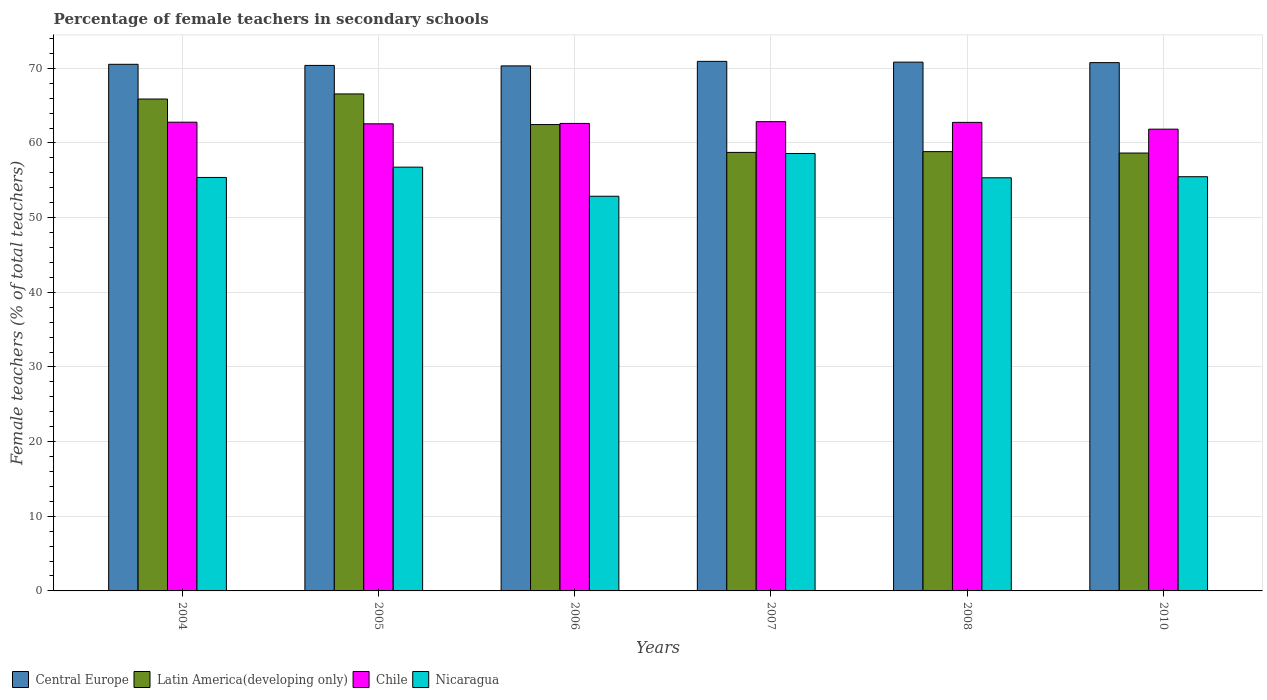How many groups of bars are there?
Offer a very short reply. 6. Are the number of bars on each tick of the X-axis equal?
Offer a very short reply. Yes. What is the label of the 4th group of bars from the left?
Give a very brief answer. 2007. In how many cases, is the number of bars for a given year not equal to the number of legend labels?
Your response must be concise. 0. What is the percentage of female teachers in Central Europe in 2004?
Offer a terse response. 70.54. Across all years, what is the maximum percentage of female teachers in Latin America(developing only)?
Your answer should be compact. 66.57. Across all years, what is the minimum percentage of female teachers in Chile?
Give a very brief answer. 61.85. In which year was the percentage of female teachers in Latin America(developing only) minimum?
Keep it short and to the point. 2010. What is the total percentage of female teachers in Latin America(developing only) in the graph?
Keep it short and to the point. 371.17. What is the difference between the percentage of female teachers in Chile in 2005 and that in 2008?
Your answer should be very brief. -0.19. What is the difference between the percentage of female teachers in Chile in 2008 and the percentage of female teachers in Central Europe in 2006?
Offer a terse response. -7.57. What is the average percentage of female teachers in Nicaragua per year?
Keep it short and to the point. 55.74. In the year 2010, what is the difference between the percentage of female teachers in Nicaragua and percentage of female teachers in Chile?
Give a very brief answer. -6.37. In how many years, is the percentage of female teachers in Nicaragua greater than 58 %?
Your response must be concise. 1. What is the ratio of the percentage of female teachers in Central Europe in 2008 to that in 2010?
Offer a very short reply. 1. What is the difference between the highest and the second highest percentage of female teachers in Chile?
Your answer should be compact. 0.07. What is the difference between the highest and the lowest percentage of female teachers in Central Europe?
Your response must be concise. 0.61. Is the sum of the percentage of female teachers in Nicaragua in 2005 and 2010 greater than the maximum percentage of female teachers in Chile across all years?
Offer a terse response. Yes. Is it the case that in every year, the sum of the percentage of female teachers in Chile and percentage of female teachers in Central Europe is greater than the sum of percentage of female teachers in Nicaragua and percentage of female teachers in Latin America(developing only)?
Ensure brevity in your answer.  Yes. What does the 1st bar from the left in 2006 represents?
Offer a terse response. Central Europe. What does the 1st bar from the right in 2006 represents?
Offer a terse response. Nicaragua. Is it the case that in every year, the sum of the percentage of female teachers in Chile and percentage of female teachers in Nicaragua is greater than the percentage of female teachers in Central Europe?
Offer a very short reply. Yes. How many bars are there?
Ensure brevity in your answer.  24. Are all the bars in the graph horizontal?
Your answer should be compact. No. How many years are there in the graph?
Make the answer very short. 6. Does the graph contain grids?
Your answer should be very brief. Yes. Where does the legend appear in the graph?
Give a very brief answer. Bottom left. How many legend labels are there?
Keep it short and to the point. 4. How are the legend labels stacked?
Give a very brief answer. Horizontal. What is the title of the graph?
Your answer should be compact. Percentage of female teachers in secondary schools. Does "Zambia" appear as one of the legend labels in the graph?
Offer a terse response. No. What is the label or title of the X-axis?
Your answer should be compact. Years. What is the label or title of the Y-axis?
Provide a succinct answer. Female teachers (% of total teachers). What is the Female teachers (% of total teachers) of Central Europe in 2004?
Give a very brief answer. 70.54. What is the Female teachers (% of total teachers) in Latin America(developing only) in 2004?
Keep it short and to the point. 65.89. What is the Female teachers (% of total teachers) in Chile in 2004?
Your answer should be compact. 62.79. What is the Female teachers (% of total teachers) of Nicaragua in 2004?
Give a very brief answer. 55.38. What is the Female teachers (% of total teachers) in Central Europe in 2005?
Provide a short and direct response. 70.39. What is the Female teachers (% of total teachers) of Latin America(developing only) in 2005?
Provide a succinct answer. 66.57. What is the Female teachers (% of total teachers) of Chile in 2005?
Keep it short and to the point. 62.57. What is the Female teachers (% of total teachers) of Nicaragua in 2005?
Ensure brevity in your answer.  56.76. What is the Female teachers (% of total teachers) of Central Europe in 2006?
Give a very brief answer. 70.33. What is the Female teachers (% of total teachers) of Latin America(developing only) in 2006?
Make the answer very short. 62.47. What is the Female teachers (% of total teachers) of Chile in 2006?
Give a very brief answer. 62.62. What is the Female teachers (% of total teachers) of Nicaragua in 2006?
Offer a very short reply. 52.87. What is the Female teachers (% of total teachers) of Central Europe in 2007?
Your answer should be very brief. 70.94. What is the Female teachers (% of total teachers) in Latin America(developing only) in 2007?
Give a very brief answer. 58.74. What is the Female teachers (% of total teachers) in Chile in 2007?
Your answer should be compact. 62.86. What is the Female teachers (% of total teachers) in Nicaragua in 2007?
Offer a terse response. 58.59. What is the Female teachers (% of total teachers) in Central Europe in 2008?
Offer a terse response. 70.83. What is the Female teachers (% of total teachers) in Latin America(developing only) in 2008?
Provide a short and direct response. 58.84. What is the Female teachers (% of total teachers) of Chile in 2008?
Your response must be concise. 62.76. What is the Female teachers (% of total teachers) in Nicaragua in 2008?
Offer a terse response. 55.34. What is the Female teachers (% of total teachers) of Central Europe in 2010?
Provide a short and direct response. 70.77. What is the Female teachers (% of total teachers) in Latin America(developing only) in 2010?
Your response must be concise. 58.65. What is the Female teachers (% of total teachers) of Chile in 2010?
Offer a terse response. 61.85. What is the Female teachers (% of total teachers) in Nicaragua in 2010?
Provide a succinct answer. 55.48. Across all years, what is the maximum Female teachers (% of total teachers) of Central Europe?
Your response must be concise. 70.94. Across all years, what is the maximum Female teachers (% of total teachers) in Latin America(developing only)?
Offer a terse response. 66.57. Across all years, what is the maximum Female teachers (% of total teachers) in Chile?
Make the answer very short. 62.86. Across all years, what is the maximum Female teachers (% of total teachers) of Nicaragua?
Offer a very short reply. 58.59. Across all years, what is the minimum Female teachers (% of total teachers) in Central Europe?
Provide a succinct answer. 70.33. Across all years, what is the minimum Female teachers (% of total teachers) of Latin America(developing only)?
Keep it short and to the point. 58.65. Across all years, what is the minimum Female teachers (% of total teachers) of Chile?
Give a very brief answer. 61.85. Across all years, what is the minimum Female teachers (% of total teachers) in Nicaragua?
Keep it short and to the point. 52.87. What is the total Female teachers (% of total teachers) of Central Europe in the graph?
Provide a short and direct response. 423.79. What is the total Female teachers (% of total teachers) in Latin America(developing only) in the graph?
Offer a very short reply. 371.17. What is the total Female teachers (% of total teachers) of Chile in the graph?
Keep it short and to the point. 375.45. What is the total Female teachers (% of total teachers) of Nicaragua in the graph?
Give a very brief answer. 334.43. What is the difference between the Female teachers (% of total teachers) in Central Europe in 2004 and that in 2005?
Ensure brevity in your answer.  0.15. What is the difference between the Female teachers (% of total teachers) in Latin America(developing only) in 2004 and that in 2005?
Your answer should be compact. -0.68. What is the difference between the Female teachers (% of total teachers) of Chile in 2004 and that in 2005?
Keep it short and to the point. 0.21. What is the difference between the Female teachers (% of total teachers) in Nicaragua in 2004 and that in 2005?
Provide a succinct answer. -1.38. What is the difference between the Female teachers (% of total teachers) in Central Europe in 2004 and that in 2006?
Your answer should be very brief. 0.21. What is the difference between the Female teachers (% of total teachers) in Latin America(developing only) in 2004 and that in 2006?
Keep it short and to the point. 3.42. What is the difference between the Female teachers (% of total teachers) in Chile in 2004 and that in 2006?
Make the answer very short. 0.16. What is the difference between the Female teachers (% of total teachers) of Nicaragua in 2004 and that in 2006?
Make the answer very short. 2.52. What is the difference between the Female teachers (% of total teachers) of Central Europe in 2004 and that in 2007?
Give a very brief answer. -0.4. What is the difference between the Female teachers (% of total teachers) of Latin America(developing only) in 2004 and that in 2007?
Ensure brevity in your answer.  7.15. What is the difference between the Female teachers (% of total teachers) of Chile in 2004 and that in 2007?
Offer a very short reply. -0.07. What is the difference between the Female teachers (% of total teachers) of Nicaragua in 2004 and that in 2007?
Give a very brief answer. -3.21. What is the difference between the Female teachers (% of total teachers) of Central Europe in 2004 and that in 2008?
Provide a short and direct response. -0.29. What is the difference between the Female teachers (% of total teachers) of Latin America(developing only) in 2004 and that in 2008?
Provide a succinct answer. 7.05. What is the difference between the Female teachers (% of total teachers) in Chile in 2004 and that in 2008?
Offer a terse response. 0.02. What is the difference between the Female teachers (% of total teachers) of Nicaragua in 2004 and that in 2008?
Make the answer very short. 0.05. What is the difference between the Female teachers (% of total teachers) in Central Europe in 2004 and that in 2010?
Give a very brief answer. -0.23. What is the difference between the Female teachers (% of total teachers) of Latin America(developing only) in 2004 and that in 2010?
Keep it short and to the point. 7.23. What is the difference between the Female teachers (% of total teachers) in Chile in 2004 and that in 2010?
Your answer should be compact. 0.93. What is the difference between the Female teachers (% of total teachers) of Nicaragua in 2004 and that in 2010?
Offer a very short reply. -0.1. What is the difference between the Female teachers (% of total teachers) in Central Europe in 2005 and that in 2006?
Offer a terse response. 0.06. What is the difference between the Female teachers (% of total teachers) of Latin America(developing only) in 2005 and that in 2006?
Your answer should be very brief. 4.1. What is the difference between the Female teachers (% of total teachers) in Chile in 2005 and that in 2006?
Provide a short and direct response. -0.05. What is the difference between the Female teachers (% of total teachers) of Nicaragua in 2005 and that in 2006?
Your answer should be compact. 3.9. What is the difference between the Female teachers (% of total teachers) of Central Europe in 2005 and that in 2007?
Your answer should be compact. -0.54. What is the difference between the Female teachers (% of total teachers) of Latin America(developing only) in 2005 and that in 2007?
Offer a terse response. 7.83. What is the difference between the Female teachers (% of total teachers) of Chile in 2005 and that in 2007?
Your answer should be very brief. -0.29. What is the difference between the Female teachers (% of total teachers) in Nicaragua in 2005 and that in 2007?
Provide a succinct answer. -1.83. What is the difference between the Female teachers (% of total teachers) in Central Europe in 2005 and that in 2008?
Offer a very short reply. -0.44. What is the difference between the Female teachers (% of total teachers) of Latin America(developing only) in 2005 and that in 2008?
Provide a short and direct response. 7.73. What is the difference between the Female teachers (% of total teachers) in Chile in 2005 and that in 2008?
Your answer should be very brief. -0.19. What is the difference between the Female teachers (% of total teachers) in Nicaragua in 2005 and that in 2008?
Give a very brief answer. 1.43. What is the difference between the Female teachers (% of total teachers) in Central Europe in 2005 and that in 2010?
Provide a short and direct response. -0.37. What is the difference between the Female teachers (% of total teachers) of Latin America(developing only) in 2005 and that in 2010?
Give a very brief answer. 7.92. What is the difference between the Female teachers (% of total teachers) in Chile in 2005 and that in 2010?
Keep it short and to the point. 0.72. What is the difference between the Female teachers (% of total teachers) in Nicaragua in 2005 and that in 2010?
Offer a very short reply. 1.28. What is the difference between the Female teachers (% of total teachers) in Central Europe in 2006 and that in 2007?
Keep it short and to the point. -0.61. What is the difference between the Female teachers (% of total teachers) of Latin America(developing only) in 2006 and that in 2007?
Make the answer very short. 3.73. What is the difference between the Female teachers (% of total teachers) of Chile in 2006 and that in 2007?
Provide a succinct answer. -0.24. What is the difference between the Female teachers (% of total teachers) in Nicaragua in 2006 and that in 2007?
Give a very brief answer. -5.73. What is the difference between the Female teachers (% of total teachers) of Central Europe in 2006 and that in 2008?
Provide a short and direct response. -0.5. What is the difference between the Female teachers (% of total teachers) of Latin America(developing only) in 2006 and that in 2008?
Provide a short and direct response. 3.63. What is the difference between the Female teachers (% of total teachers) of Chile in 2006 and that in 2008?
Offer a terse response. -0.14. What is the difference between the Female teachers (% of total teachers) of Nicaragua in 2006 and that in 2008?
Give a very brief answer. -2.47. What is the difference between the Female teachers (% of total teachers) of Central Europe in 2006 and that in 2010?
Ensure brevity in your answer.  -0.44. What is the difference between the Female teachers (% of total teachers) of Latin America(developing only) in 2006 and that in 2010?
Offer a very short reply. 3.82. What is the difference between the Female teachers (% of total teachers) in Chile in 2006 and that in 2010?
Provide a succinct answer. 0.77. What is the difference between the Female teachers (% of total teachers) in Nicaragua in 2006 and that in 2010?
Ensure brevity in your answer.  -2.62. What is the difference between the Female teachers (% of total teachers) of Central Europe in 2007 and that in 2008?
Provide a succinct answer. 0.1. What is the difference between the Female teachers (% of total teachers) in Latin America(developing only) in 2007 and that in 2008?
Offer a terse response. -0.1. What is the difference between the Female teachers (% of total teachers) of Chile in 2007 and that in 2008?
Make the answer very short. 0.1. What is the difference between the Female teachers (% of total teachers) in Nicaragua in 2007 and that in 2008?
Offer a very short reply. 3.26. What is the difference between the Female teachers (% of total teachers) of Central Europe in 2007 and that in 2010?
Make the answer very short. 0.17. What is the difference between the Female teachers (% of total teachers) of Latin America(developing only) in 2007 and that in 2010?
Make the answer very short. 0.09. What is the difference between the Female teachers (% of total teachers) of Chile in 2007 and that in 2010?
Ensure brevity in your answer.  1.01. What is the difference between the Female teachers (% of total teachers) in Nicaragua in 2007 and that in 2010?
Your response must be concise. 3.11. What is the difference between the Female teachers (% of total teachers) in Central Europe in 2008 and that in 2010?
Make the answer very short. 0.06. What is the difference between the Female teachers (% of total teachers) in Latin America(developing only) in 2008 and that in 2010?
Give a very brief answer. 0.19. What is the difference between the Female teachers (% of total teachers) in Chile in 2008 and that in 2010?
Offer a terse response. 0.91. What is the difference between the Female teachers (% of total teachers) of Nicaragua in 2008 and that in 2010?
Your answer should be compact. -0.15. What is the difference between the Female teachers (% of total teachers) in Central Europe in 2004 and the Female teachers (% of total teachers) in Latin America(developing only) in 2005?
Provide a short and direct response. 3.97. What is the difference between the Female teachers (% of total teachers) of Central Europe in 2004 and the Female teachers (% of total teachers) of Chile in 2005?
Make the answer very short. 7.97. What is the difference between the Female teachers (% of total teachers) of Central Europe in 2004 and the Female teachers (% of total teachers) of Nicaragua in 2005?
Offer a very short reply. 13.78. What is the difference between the Female teachers (% of total teachers) in Latin America(developing only) in 2004 and the Female teachers (% of total teachers) in Chile in 2005?
Your answer should be compact. 3.32. What is the difference between the Female teachers (% of total teachers) of Latin America(developing only) in 2004 and the Female teachers (% of total teachers) of Nicaragua in 2005?
Ensure brevity in your answer.  9.12. What is the difference between the Female teachers (% of total teachers) in Chile in 2004 and the Female teachers (% of total teachers) in Nicaragua in 2005?
Keep it short and to the point. 6.02. What is the difference between the Female teachers (% of total teachers) of Central Europe in 2004 and the Female teachers (% of total teachers) of Latin America(developing only) in 2006?
Ensure brevity in your answer.  8.07. What is the difference between the Female teachers (% of total teachers) of Central Europe in 2004 and the Female teachers (% of total teachers) of Chile in 2006?
Offer a very short reply. 7.92. What is the difference between the Female teachers (% of total teachers) in Central Europe in 2004 and the Female teachers (% of total teachers) in Nicaragua in 2006?
Your answer should be compact. 17.67. What is the difference between the Female teachers (% of total teachers) of Latin America(developing only) in 2004 and the Female teachers (% of total teachers) of Chile in 2006?
Keep it short and to the point. 3.27. What is the difference between the Female teachers (% of total teachers) in Latin America(developing only) in 2004 and the Female teachers (% of total teachers) in Nicaragua in 2006?
Give a very brief answer. 13.02. What is the difference between the Female teachers (% of total teachers) in Chile in 2004 and the Female teachers (% of total teachers) in Nicaragua in 2006?
Ensure brevity in your answer.  9.92. What is the difference between the Female teachers (% of total teachers) in Central Europe in 2004 and the Female teachers (% of total teachers) in Latin America(developing only) in 2007?
Ensure brevity in your answer.  11.8. What is the difference between the Female teachers (% of total teachers) in Central Europe in 2004 and the Female teachers (% of total teachers) in Chile in 2007?
Give a very brief answer. 7.68. What is the difference between the Female teachers (% of total teachers) of Central Europe in 2004 and the Female teachers (% of total teachers) of Nicaragua in 2007?
Offer a terse response. 11.95. What is the difference between the Female teachers (% of total teachers) of Latin America(developing only) in 2004 and the Female teachers (% of total teachers) of Chile in 2007?
Ensure brevity in your answer.  3.03. What is the difference between the Female teachers (% of total teachers) in Latin America(developing only) in 2004 and the Female teachers (% of total teachers) in Nicaragua in 2007?
Provide a short and direct response. 7.29. What is the difference between the Female teachers (% of total teachers) in Chile in 2004 and the Female teachers (% of total teachers) in Nicaragua in 2007?
Offer a very short reply. 4.19. What is the difference between the Female teachers (% of total teachers) in Central Europe in 2004 and the Female teachers (% of total teachers) in Latin America(developing only) in 2008?
Ensure brevity in your answer.  11.7. What is the difference between the Female teachers (% of total teachers) in Central Europe in 2004 and the Female teachers (% of total teachers) in Chile in 2008?
Offer a terse response. 7.78. What is the difference between the Female teachers (% of total teachers) in Central Europe in 2004 and the Female teachers (% of total teachers) in Nicaragua in 2008?
Provide a short and direct response. 15.2. What is the difference between the Female teachers (% of total teachers) in Latin America(developing only) in 2004 and the Female teachers (% of total teachers) in Chile in 2008?
Offer a terse response. 3.13. What is the difference between the Female teachers (% of total teachers) in Latin America(developing only) in 2004 and the Female teachers (% of total teachers) in Nicaragua in 2008?
Offer a very short reply. 10.55. What is the difference between the Female teachers (% of total teachers) of Chile in 2004 and the Female teachers (% of total teachers) of Nicaragua in 2008?
Your answer should be compact. 7.45. What is the difference between the Female teachers (% of total teachers) of Central Europe in 2004 and the Female teachers (% of total teachers) of Latin America(developing only) in 2010?
Ensure brevity in your answer.  11.89. What is the difference between the Female teachers (% of total teachers) of Central Europe in 2004 and the Female teachers (% of total teachers) of Chile in 2010?
Make the answer very short. 8.69. What is the difference between the Female teachers (% of total teachers) of Central Europe in 2004 and the Female teachers (% of total teachers) of Nicaragua in 2010?
Ensure brevity in your answer.  15.06. What is the difference between the Female teachers (% of total teachers) of Latin America(developing only) in 2004 and the Female teachers (% of total teachers) of Chile in 2010?
Provide a succinct answer. 4.04. What is the difference between the Female teachers (% of total teachers) of Latin America(developing only) in 2004 and the Female teachers (% of total teachers) of Nicaragua in 2010?
Your response must be concise. 10.41. What is the difference between the Female teachers (% of total teachers) of Chile in 2004 and the Female teachers (% of total teachers) of Nicaragua in 2010?
Your answer should be compact. 7.3. What is the difference between the Female teachers (% of total teachers) of Central Europe in 2005 and the Female teachers (% of total teachers) of Latin America(developing only) in 2006?
Your response must be concise. 7.92. What is the difference between the Female teachers (% of total teachers) in Central Europe in 2005 and the Female teachers (% of total teachers) in Chile in 2006?
Your answer should be compact. 7.77. What is the difference between the Female teachers (% of total teachers) in Central Europe in 2005 and the Female teachers (% of total teachers) in Nicaragua in 2006?
Make the answer very short. 17.53. What is the difference between the Female teachers (% of total teachers) of Latin America(developing only) in 2005 and the Female teachers (% of total teachers) of Chile in 2006?
Ensure brevity in your answer.  3.95. What is the difference between the Female teachers (% of total teachers) in Latin America(developing only) in 2005 and the Female teachers (% of total teachers) in Nicaragua in 2006?
Your answer should be very brief. 13.71. What is the difference between the Female teachers (% of total teachers) in Chile in 2005 and the Female teachers (% of total teachers) in Nicaragua in 2006?
Provide a short and direct response. 9.7. What is the difference between the Female teachers (% of total teachers) in Central Europe in 2005 and the Female teachers (% of total teachers) in Latin America(developing only) in 2007?
Your response must be concise. 11.65. What is the difference between the Female teachers (% of total teachers) of Central Europe in 2005 and the Female teachers (% of total teachers) of Chile in 2007?
Provide a short and direct response. 7.54. What is the difference between the Female teachers (% of total teachers) of Central Europe in 2005 and the Female teachers (% of total teachers) of Nicaragua in 2007?
Your answer should be very brief. 11.8. What is the difference between the Female teachers (% of total teachers) of Latin America(developing only) in 2005 and the Female teachers (% of total teachers) of Chile in 2007?
Offer a very short reply. 3.71. What is the difference between the Female teachers (% of total teachers) in Latin America(developing only) in 2005 and the Female teachers (% of total teachers) in Nicaragua in 2007?
Offer a terse response. 7.98. What is the difference between the Female teachers (% of total teachers) in Chile in 2005 and the Female teachers (% of total teachers) in Nicaragua in 2007?
Offer a very short reply. 3.98. What is the difference between the Female teachers (% of total teachers) in Central Europe in 2005 and the Female teachers (% of total teachers) in Latin America(developing only) in 2008?
Your answer should be compact. 11.55. What is the difference between the Female teachers (% of total teachers) of Central Europe in 2005 and the Female teachers (% of total teachers) of Chile in 2008?
Offer a very short reply. 7.63. What is the difference between the Female teachers (% of total teachers) in Central Europe in 2005 and the Female teachers (% of total teachers) in Nicaragua in 2008?
Your answer should be compact. 15.05. What is the difference between the Female teachers (% of total teachers) of Latin America(developing only) in 2005 and the Female teachers (% of total teachers) of Chile in 2008?
Offer a very short reply. 3.81. What is the difference between the Female teachers (% of total teachers) of Latin America(developing only) in 2005 and the Female teachers (% of total teachers) of Nicaragua in 2008?
Your answer should be very brief. 11.23. What is the difference between the Female teachers (% of total teachers) of Chile in 2005 and the Female teachers (% of total teachers) of Nicaragua in 2008?
Make the answer very short. 7.23. What is the difference between the Female teachers (% of total teachers) of Central Europe in 2005 and the Female teachers (% of total teachers) of Latin America(developing only) in 2010?
Your answer should be very brief. 11.74. What is the difference between the Female teachers (% of total teachers) of Central Europe in 2005 and the Female teachers (% of total teachers) of Chile in 2010?
Your answer should be very brief. 8.54. What is the difference between the Female teachers (% of total teachers) in Central Europe in 2005 and the Female teachers (% of total teachers) in Nicaragua in 2010?
Keep it short and to the point. 14.91. What is the difference between the Female teachers (% of total teachers) of Latin America(developing only) in 2005 and the Female teachers (% of total teachers) of Chile in 2010?
Make the answer very short. 4.72. What is the difference between the Female teachers (% of total teachers) in Latin America(developing only) in 2005 and the Female teachers (% of total teachers) in Nicaragua in 2010?
Give a very brief answer. 11.09. What is the difference between the Female teachers (% of total teachers) of Chile in 2005 and the Female teachers (% of total teachers) of Nicaragua in 2010?
Make the answer very short. 7.09. What is the difference between the Female teachers (% of total teachers) in Central Europe in 2006 and the Female teachers (% of total teachers) in Latin America(developing only) in 2007?
Your response must be concise. 11.59. What is the difference between the Female teachers (% of total teachers) of Central Europe in 2006 and the Female teachers (% of total teachers) of Chile in 2007?
Offer a terse response. 7.47. What is the difference between the Female teachers (% of total teachers) of Central Europe in 2006 and the Female teachers (% of total teachers) of Nicaragua in 2007?
Ensure brevity in your answer.  11.74. What is the difference between the Female teachers (% of total teachers) in Latin America(developing only) in 2006 and the Female teachers (% of total teachers) in Chile in 2007?
Provide a short and direct response. -0.39. What is the difference between the Female teachers (% of total teachers) of Latin America(developing only) in 2006 and the Female teachers (% of total teachers) of Nicaragua in 2007?
Ensure brevity in your answer.  3.88. What is the difference between the Female teachers (% of total teachers) in Chile in 2006 and the Female teachers (% of total teachers) in Nicaragua in 2007?
Provide a short and direct response. 4.03. What is the difference between the Female teachers (% of total teachers) of Central Europe in 2006 and the Female teachers (% of total teachers) of Latin America(developing only) in 2008?
Offer a terse response. 11.49. What is the difference between the Female teachers (% of total teachers) in Central Europe in 2006 and the Female teachers (% of total teachers) in Chile in 2008?
Offer a terse response. 7.57. What is the difference between the Female teachers (% of total teachers) in Central Europe in 2006 and the Female teachers (% of total teachers) in Nicaragua in 2008?
Make the answer very short. 14.99. What is the difference between the Female teachers (% of total teachers) of Latin America(developing only) in 2006 and the Female teachers (% of total teachers) of Chile in 2008?
Ensure brevity in your answer.  -0.29. What is the difference between the Female teachers (% of total teachers) of Latin America(developing only) in 2006 and the Female teachers (% of total teachers) of Nicaragua in 2008?
Offer a terse response. 7.13. What is the difference between the Female teachers (% of total teachers) in Chile in 2006 and the Female teachers (% of total teachers) in Nicaragua in 2008?
Ensure brevity in your answer.  7.28. What is the difference between the Female teachers (% of total teachers) of Central Europe in 2006 and the Female teachers (% of total teachers) of Latin America(developing only) in 2010?
Provide a succinct answer. 11.68. What is the difference between the Female teachers (% of total teachers) in Central Europe in 2006 and the Female teachers (% of total teachers) in Chile in 2010?
Provide a succinct answer. 8.48. What is the difference between the Female teachers (% of total teachers) in Central Europe in 2006 and the Female teachers (% of total teachers) in Nicaragua in 2010?
Provide a succinct answer. 14.85. What is the difference between the Female teachers (% of total teachers) of Latin America(developing only) in 2006 and the Female teachers (% of total teachers) of Chile in 2010?
Your answer should be compact. 0.62. What is the difference between the Female teachers (% of total teachers) in Latin America(developing only) in 2006 and the Female teachers (% of total teachers) in Nicaragua in 2010?
Your response must be concise. 6.99. What is the difference between the Female teachers (% of total teachers) in Chile in 2006 and the Female teachers (% of total teachers) in Nicaragua in 2010?
Your answer should be compact. 7.14. What is the difference between the Female teachers (% of total teachers) of Central Europe in 2007 and the Female teachers (% of total teachers) of Latin America(developing only) in 2008?
Provide a succinct answer. 12.09. What is the difference between the Female teachers (% of total teachers) in Central Europe in 2007 and the Female teachers (% of total teachers) in Chile in 2008?
Make the answer very short. 8.17. What is the difference between the Female teachers (% of total teachers) in Central Europe in 2007 and the Female teachers (% of total teachers) in Nicaragua in 2008?
Offer a terse response. 15.6. What is the difference between the Female teachers (% of total teachers) in Latin America(developing only) in 2007 and the Female teachers (% of total teachers) in Chile in 2008?
Ensure brevity in your answer.  -4.02. What is the difference between the Female teachers (% of total teachers) of Latin America(developing only) in 2007 and the Female teachers (% of total teachers) of Nicaragua in 2008?
Ensure brevity in your answer.  3.4. What is the difference between the Female teachers (% of total teachers) in Chile in 2007 and the Female teachers (% of total teachers) in Nicaragua in 2008?
Offer a very short reply. 7.52. What is the difference between the Female teachers (% of total teachers) in Central Europe in 2007 and the Female teachers (% of total teachers) in Latin America(developing only) in 2010?
Ensure brevity in your answer.  12.28. What is the difference between the Female teachers (% of total teachers) in Central Europe in 2007 and the Female teachers (% of total teachers) in Chile in 2010?
Your answer should be very brief. 9.08. What is the difference between the Female teachers (% of total teachers) in Central Europe in 2007 and the Female teachers (% of total teachers) in Nicaragua in 2010?
Offer a very short reply. 15.45. What is the difference between the Female teachers (% of total teachers) of Latin America(developing only) in 2007 and the Female teachers (% of total teachers) of Chile in 2010?
Keep it short and to the point. -3.11. What is the difference between the Female teachers (% of total teachers) in Latin America(developing only) in 2007 and the Female teachers (% of total teachers) in Nicaragua in 2010?
Provide a succinct answer. 3.26. What is the difference between the Female teachers (% of total teachers) of Chile in 2007 and the Female teachers (% of total teachers) of Nicaragua in 2010?
Offer a very short reply. 7.37. What is the difference between the Female teachers (% of total teachers) in Central Europe in 2008 and the Female teachers (% of total teachers) in Latin America(developing only) in 2010?
Your answer should be very brief. 12.18. What is the difference between the Female teachers (% of total teachers) of Central Europe in 2008 and the Female teachers (% of total teachers) of Chile in 2010?
Offer a terse response. 8.98. What is the difference between the Female teachers (% of total teachers) in Central Europe in 2008 and the Female teachers (% of total teachers) in Nicaragua in 2010?
Provide a short and direct response. 15.35. What is the difference between the Female teachers (% of total teachers) of Latin America(developing only) in 2008 and the Female teachers (% of total teachers) of Chile in 2010?
Offer a terse response. -3.01. What is the difference between the Female teachers (% of total teachers) of Latin America(developing only) in 2008 and the Female teachers (% of total teachers) of Nicaragua in 2010?
Provide a succinct answer. 3.36. What is the difference between the Female teachers (% of total teachers) in Chile in 2008 and the Female teachers (% of total teachers) in Nicaragua in 2010?
Provide a short and direct response. 7.28. What is the average Female teachers (% of total teachers) in Central Europe per year?
Provide a succinct answer. 70.63. What is the average Female teachers (% of total teachers) in Latin America(developing only) per year?
Your response must be concise. 61.86. What is the average Female teachers (% of total teachers) in Chile per year?
Keep it short and to the point. 62.57. What is the average Female teachers (% of total teachers) in Nicaragua per year?
Provide a short and direct response. 55.74. In the year 2004, what is the difference between the Female teachers (% of total teachers) of Central Europe and Female teachers (% of total teachers) of Latin America(developing only)?
Provide a short and direct response. 4.65. In the year 2004, what is the difference between the Female teachers (% of total teachers) in Central Europe and Female teachers (% of total teachers) in Chile?
Offer a very short reply. 7.75. In the year 2004, what is the difference between the Female teachers (% of total teachers) of Central Europe and Female teachers (% of total teachers) of Nicaragua?
Provide a succinct answer. 15.16. In the year 2004, what is the difference between the Female teachers (% of total teachers) of Latin America(developing only) and Female teachers (% of total teachers) of Chile?
Offer a terse response. 3.1. In the year 2004, what is the difference between the Female teachers (% of total teachers) of Latin America(developing only) and Female teachers (% of total teachers) of Nicaragua?
Ensure brevity in your answer.  10.51. In the year 2004, what is the difference between the Female teachers (% of total teachers) of Chile and Female teachers (% of total teachers) of Nicaragua?
Offer a terse response. 7.4. In the year 2005, what is the difference between the Female teachers (% of total teachers) of Central Europe and Female teachers (% of total teachers) of Latin America(developing only)?
Keep it short and to the point. 3.82. In the year 2005, what is the difference between the Female teachers (% of total teachers) of Central Europe and Female teachers (% of total teachers) of Chile?
Offer a very short reply. 7.82. In the year 2005, what is the difference between the Female teachers (% of total teachers) in Central Europe and Female teachers (% of total teachers) in Nicaragua?
Provide a short and direct response. 13.63. In the year 2005, what is the difference between the Female teachers (% of total teachers) in Latin America(developing only) and Female teachers (% of total teachers) in Chile?
Your answer should be compact. 4. In the year 2005, what is the difference between the Female teachers (% of total teachers) of Latin America(developing only) and Female teachers (% of total teachers) of Nicaragua?
Provide a succinct answer. 9.81. In the year 2005, what is the difference between the Female teachers (% of total teachers) of Chile and Female teachers (% of total teachers) of Nicaragua?
Ensure brevity in your answer.  5.81. In the year 2006, what is the difference between the Female teachers (% of total teachers) in Central Europe and Female teachers (% of total teachers) in Latin America(developing only)?
Ensure brevity in your answer.  7.86. In the year 2006, what is the difference between the Female teachers (% of total teachers) of Central Europe and Female teachers (% of total teachers) of Chile?
Make the answer very short. 7.71. In the year 2006, what is the difference between the Female teachers (% of total teachers) in Central Europe and Female teachers (% of total teachers) in Nicaragua?
Provide a succinct answer. 17.46. In the year 2006, what is the difference between the Female teachers (% of total teachers) in Latin America(developing only) and Female teachers (% of total teachers) in Nicaragua?
Provide a short and direct response. 9.6. In the year 2006, what is the difference between the Female teachers (% of total teachers) of Chile and Female teachers (% of total teachers) of Nicaragua?
Ensure brevity in your answer.  9.75. In the year 2007, what is the difference between the Female teachers (% of total teachers) of Central Europe and Female teachers (% of total teachers) of Latin America(developing only)?
Your answer should be compact. 12.19. In the year 2007, what is the difference between the Female teachers (% of total teachers) of Central Europe and Female teachers (% of total teachers) of Chile?
Provide a succinct answer. 8.08. In the year 2007, what is the difference between the Female teachers (% of total teachers) in Central Europe and Female teachers (% of total teachers) in Nicaragua?
Your answer should be very brief. 12.34. In the year 2007, what is the difference between the Female teachers (% of total teachers) in Latin America(developing only) and Female teachers (% of total teachers) in Chile?
Provide a short and direct response. -4.12. In the year 2007, what is the difference between the Female teachers (% of total teachers) of Latin America(developing only) and Female teachers (% of total teachers) of Nicaragua?
Offer a terse response. 0.15. In the year 2007, what is the difference between the Female teachers (% of total teachers) of Chile and Female teachers (% of total teachers) of Nicaragua?
Give a very brief answer. 4.26. In the year 2008, what is the difference between the Female teachers (% of total teachers) of Central Europe and Female teachers (% of total teachers) of Latin America(developing only)?
Your response must be concise. 11.99. In the year 2008, what is the difference between the Female teachers (% of total teachers) of Central Europe and Female teachers (% of total teachers) of Chile?
Offer a very short reply. 8.07. In the year 2008, what is the difference between the Female teachers (% of total teachers) of Central Europe and Female teachers (% of total teachers) of Nicaragua?
Your answer should be compact. 15.49. In the year 2008, what is the difference between the Female teachers (% of total teachers) of Latin America(developing only) and Female teachers (% of total teachers) of Chile?
Keep it short and to the point. -3.92. In the year 2008, what is the difference between the Female teachers (% of total teachers) in Latin America(developing only) and Female teachers (% of total teachers) in Nicaragua?
Your answer should be very brief. 3.5. In the year 2008, what is the difference between the Female teachers (% of total teachers) in Chile and Female teachers (% of total teachers) in Nicaragua?
Ensure brevity in your answer.  7.42. In the year 2010, what is the difference between the Female teachers (% of total teachers) in Central Europe and Female teachers (% of total teachers) in Latin America(developing only)?
Keep it short and to the point. 12.11. In the year 2010, what is the difference between the Female teachers (% of total teachers) of Central Europe and Female teachers (% of total teachers) of Chile?
Make the answer very short. 8.91. In the year 2010, what is the difference between the Female teachers (% of total teachers) of Central Europe and Female teachers (% of total teachers) of Nicaragua?
Provide a short and direct response. 15.28. In the year 2010, what is the difference between the Female teachers (% of total teachers) in Latin America(developing only) and Female teachers (% of total teachers) in Chile?
Make the answer very short. -3.2. In the year 2010, what is the difference between the Female teachers (% of total teachers) of Latin America(developing only) and Female teachers (% of total teachers) of Nicaragua?
Offer a very short reply. 3.17. In the year 2010, what is the difference between the Female teachers (% of total teachers) in Chile and Female teachers (% of total teachers) in Nicaragua?
Provide a short and direct response. 6.37. What is the ratio of the Female teachers (% of total teachers) of Central Europe in 2004 to that in 2005?
Provide a succinct answer. 1. What is the ratio of the Female teachers (% of total teachers) in Latin America(developing only) in 2004 to that in 2005?
Give a very brief answer. 0.99. What is the ratio of the Female teachers (% of total teachers) of Nicaragua in 2004 to that in 2005?
Ensure brevity in your answer.  0.98. What is the ratio of the Female teachers (% of total teachers) in Latin America(developing only) in 2004 to that in 2006?
Provide a short and direct response. 1.05. What is the ratio of the Female teachers (% of total teachers) of Chile in 2004 to that in 2006?
Provide a succinct answer. 1. What is the ratio of the Female teachers (% of total teachers) in Nicaragua in 2004 to that in 2006?
Your answer should be compact. 1.05. What is the ratio of the Female teachers (% of total teachers) in Latin America(developing only) in 2004 to that in 2007?
Offer a very short reply. 1.12. What is the ratio of the Female teachers (% of total teachers) in Chile in 2004 to that in 2007?
Your answer should be very brief. 1. What is the ratio of the Female teachers (% of total teachers) of Nicaragua in 2004 to that in 2007?
Your response must be concise. 0.95. What is the ratio of the Female teachers (% of total teachers) of Latin America(developing only) in 2004 to that in 2008?
Offer a very short reply. 1.12. What is the ratio of the Female teachers (% of total teachers) in Chile in 2004 to that in 2008?
Make the answer very short. 1. What is the ratio of the Female teachers (% of total teachers) of Latin America(developing only) in 2004 to that in 2010?
Make the answer very short. 1.12. What is the ratio of the Female teachers (% of total teachers) in Chile in 2004 to that in 2010?
Provide a succinct answer. 1.02. What is the ratio of the Female teachers (% of total teachers) of Nicaragua in 2004 to that in 2010?
Give a very brief answer. 1. What is the ratio of the Female teachers (% of total teachers) in Latin America(developing only) in 2005 to that in 2006?
Make the answer very short. 1.07. What is the ratio of the Female teachers (% of total teachers) of Nicaragua in 2005 to that in 2006?
Offer a very short reply. 1.07. What is the ratio of the Female teachers (% of total teachers) in Central Europe in 2005 to that in 2007?
Make the answer very short. 0.99. What is the ratio of the Female teachers (% of total teachers) in Latin America(developing only) in 2005 to that in 2007?
Provide a short and direct response. 1.13. What is the ratio of the Female teachers (% of total teachers) in Chile in 2005 to that in 2007?
Your answer should be compact. 1. What is the ratio of the Female teachers (% of total teachers) of Nicaragua in 2005 to that in 2007?
Offer a terse response. 0.97. What is the ratio of the Female teachers (% of total teachers) in Central Europe in 2005 to that in 2008?
Your response must be concise. 0.99. What is the ratio of the Female teachers (% of total teachers) in Latin America(developing only) in 2005 to that in 2008?
Your answer should be compact. 1.13. What is the ratio of the Female teachers (% of total teachers) in Nicaragua in 2005 to that in 2008?
Your response must be concise. 1.03. What is the ratio of the Female teachers (% of total teachers) in Latin America(developing only) in 2005 to that in 2010?
Provide a short and direct response. 1.14. What is the ratio of the Female teachers (% of total teachers) in Chile in 2005 to that in 2010?
Make the answer very short. 1.01. What is the ratio of the Female teachers (% of total teachers) of Nicaragua in 2005 to that in 2010?
Your response must be concise. 1.02. What is the ratio of the Female teachers (% of total teachers) of Central Europe in 2006 to that in 2007?
Keep it short and to the point. 0.99. What is the ratio of the Female teachers (% of total teachers) in Latin America(developing only) in 2006 to that in 2007?
Your response must be concise. 1.06. What is the ratio of the Female teachers (% of total teachers) in Nicaragua in 2006 to that in 2007?
Give a very brief answer. 0.9. What is the ratio of the Female teachers (% of total teachers) of Latin America(developing only) in 2006 to that in 2008?
Your answer should be very brief. 1.06. What is the ratio of the Female teachers (% of total teachers) in Nicaragua in 2006 to that in 2008?
Make the answer very short. 0.96. What is the ratio of the Female teachers (% of total teachers) of Latin America(developing only) in 2006 to that in 2010?
Your response must be concise. 1.07. What is the ratio of the Female teachers (% of total teachers) of Chile in 2006 to that in 2010?
Make the answer very short. 1.01. What is the ratio of the Female teachers (% of total teachers) of Nicaragua in 2006 to that in 2010?
Provide a short and direct response. 0.95. What is the ratio of the Female teachers (% of total teachers) of Latin America(developing only) in 2007 to that in 2008?
Provide a short and direct response. 1. What is the ratio of the Female teachers (% of total teachers) of Nicaragua in 2007 to that in 2008?
Your answer should be compact. 1.06. What is the ratio of the Female teachers (% of total teachers) in Central Europe in 2007 to that in 2010?
Your response must be concise. 1. What is the ratio of the Female teachers (% of total teachers) in Latin America(developing only) in 2007 to that in 2010?
Provide a succinct answer. 1. What is the ratio of the Female teachers (% of total teachers) of Chile in 2007 to that in 2010?
Provide a short and direct response. 1.02. What is the ratio of the Female teachers (% of total teachers) of Nicaragua in 2007 to that in 2010?
Offer a very short reply. 1.06. What is the ratio of the Female teachers (% of total teachers) of Central Europe in 2008 to that in 2010?
Your response must be concise. 1. What is the ratio of the Female teachers (% of total teachers) of Latin America(developing only) in 2008 to that in 2010?
Offer a very short reply. 1. What is the ratio of the Female teachers (% of total teachers) of Chile in 2008 to that in 2010?
Provide a short and direct response. 1.01. What is the difference between the highest and the second highest Female teachers (% of total teachers) of Central Europe?
Provide a succinct answer. 0.1. What is the difference between the highest and the second highest Female teachers (% of total teachers) in Latin America(developing only)?
Your response must be concise. 0.68. What is the difference between the highest and the second highest Female teachers (% of total teachers) in Chile?
Your answer should be compact. 0.07. What is the difference between the highest and the second highest Female teachers (% of total teachers) of Nicaragua?
Keep it short and to the point. 1.83. What is the difference between the highest and the lowest Female teachers (% of total teachers) of Central Europe?
Your response must be concise. 0.61. What is the difference between the highest and the lowest Female teachers (% of total teachers) in Latin America(developing only)?
Your answer should be very brief. 7.92. What is the difference between the highest and the lowest Female teachers (% of total teachers) in Chile?
Offer a very short reply. 1.01. What is the difference between the highest and the lowest Female teachers (% of total teachers) in Nicaragua?
Provide a succinct answer. 5.73. 